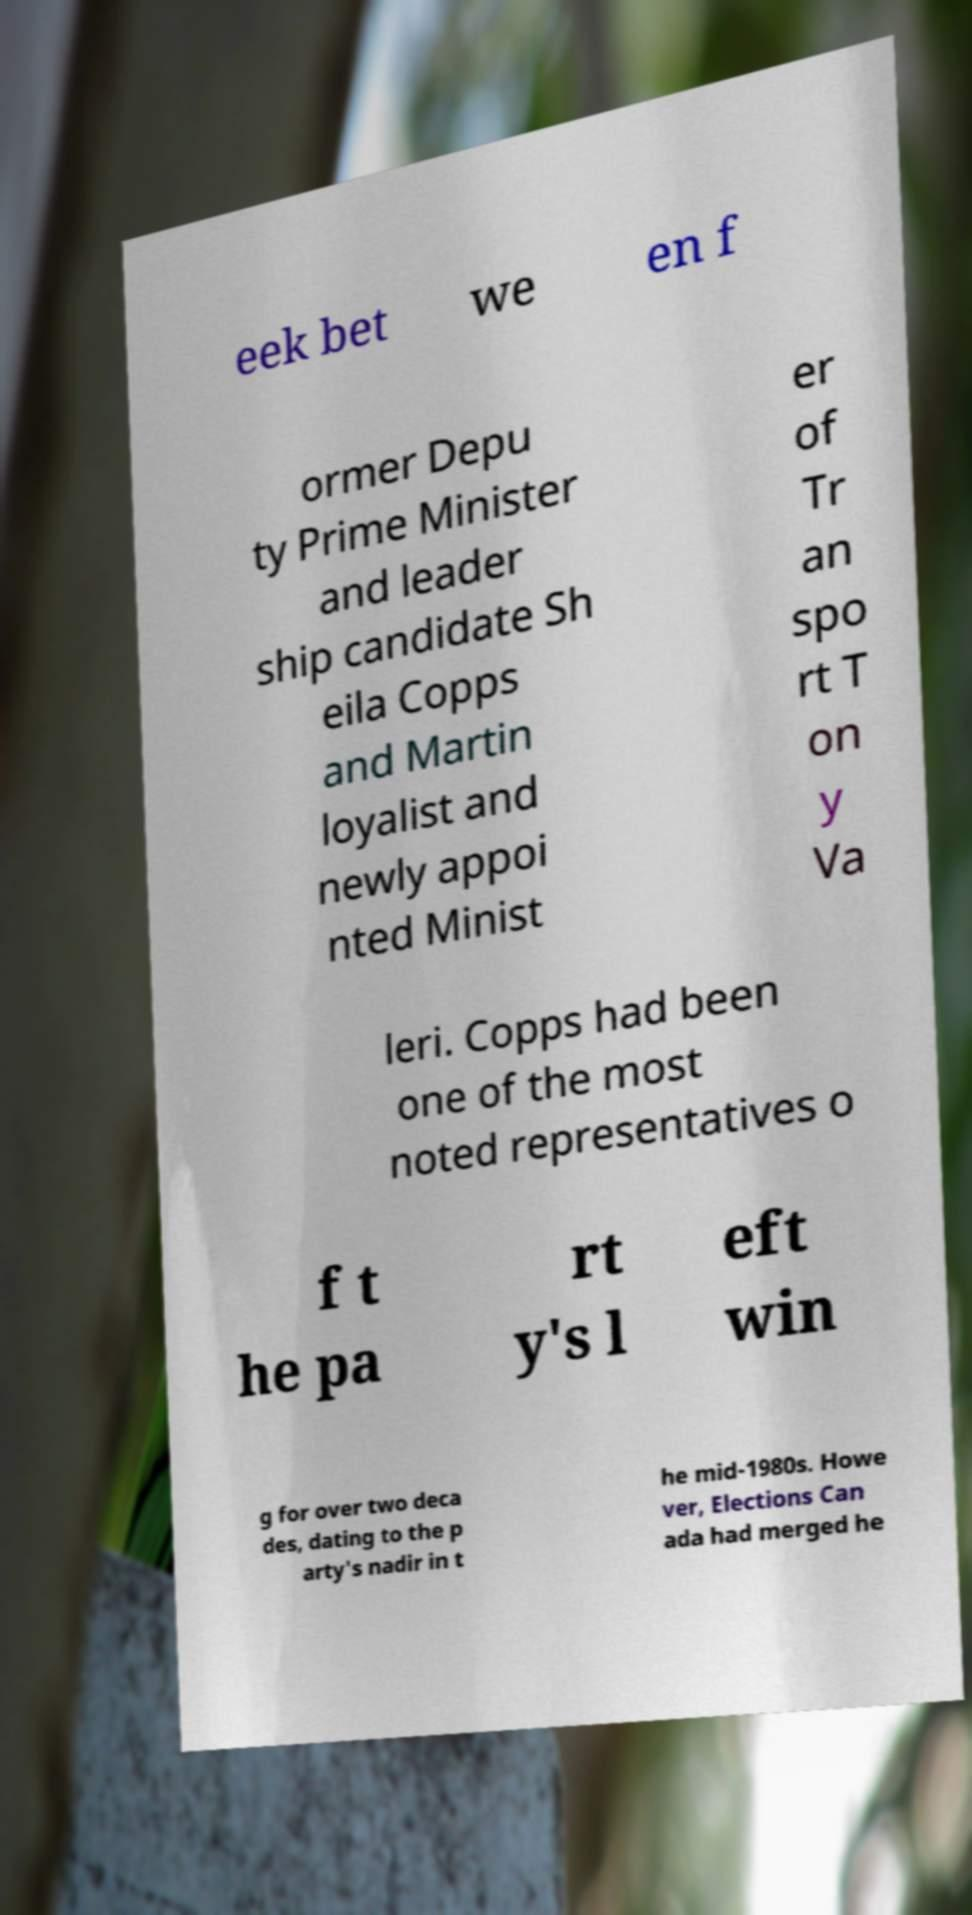Can you accurately transcribe the text from the provided image for me? eek bet we en f ormer Depu ty Prime Minister and leader ship candidate Sh eila Copps and Martin loyalist and newly appoi nted Minist er of Tr an spo rt T on y Va leri. Copps had been one of the most noted representatives o f t he pa rt y's l eft win g for over two deca des, dating to the p arty's nadir in t he mid-1980s. Howe ver, Elections Can ada had merged he 